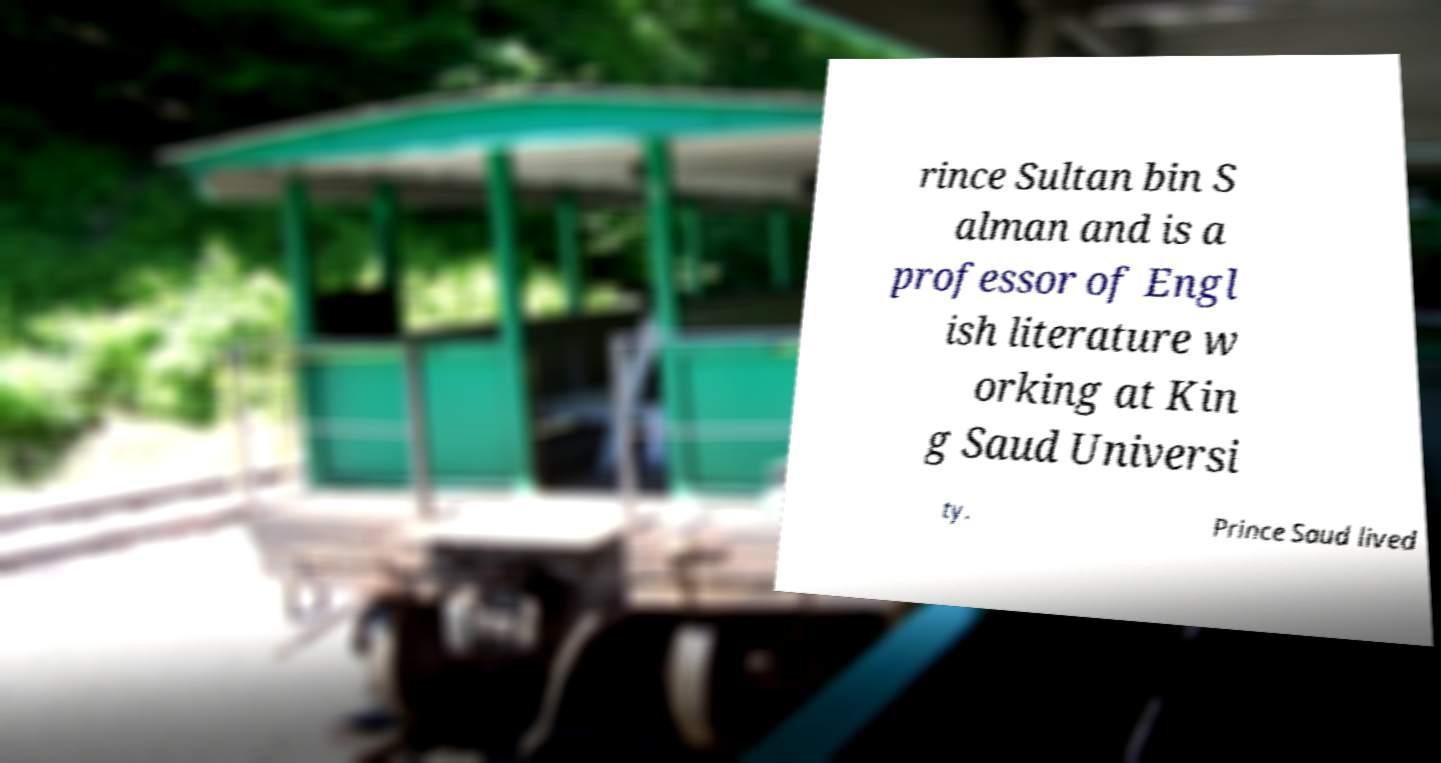Could you assist in decoding the text presented in this image and type it out clearly? rince Sultan bin S alman and is a professor of Engl ish literature w orking at Kin g Saud Universi ty. Prince Saud lived 